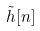<formula> <loc_0><loc_0><loc_500><loc_500>\tilde { h } [ n ]</formula> 